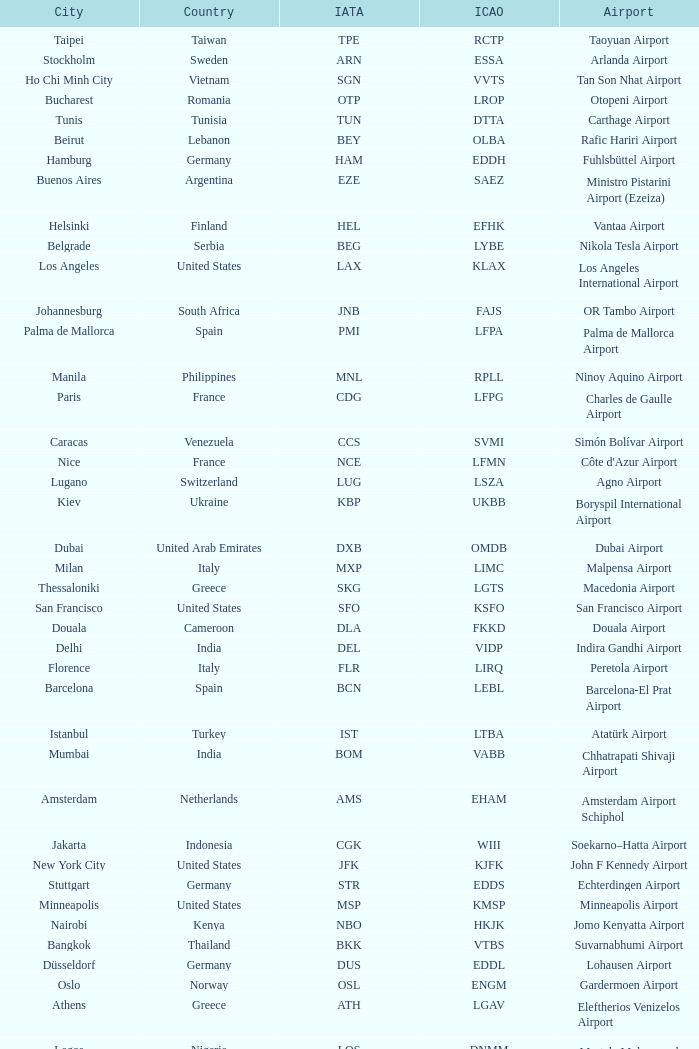What is the ICAO of Douala city? FKKD. 